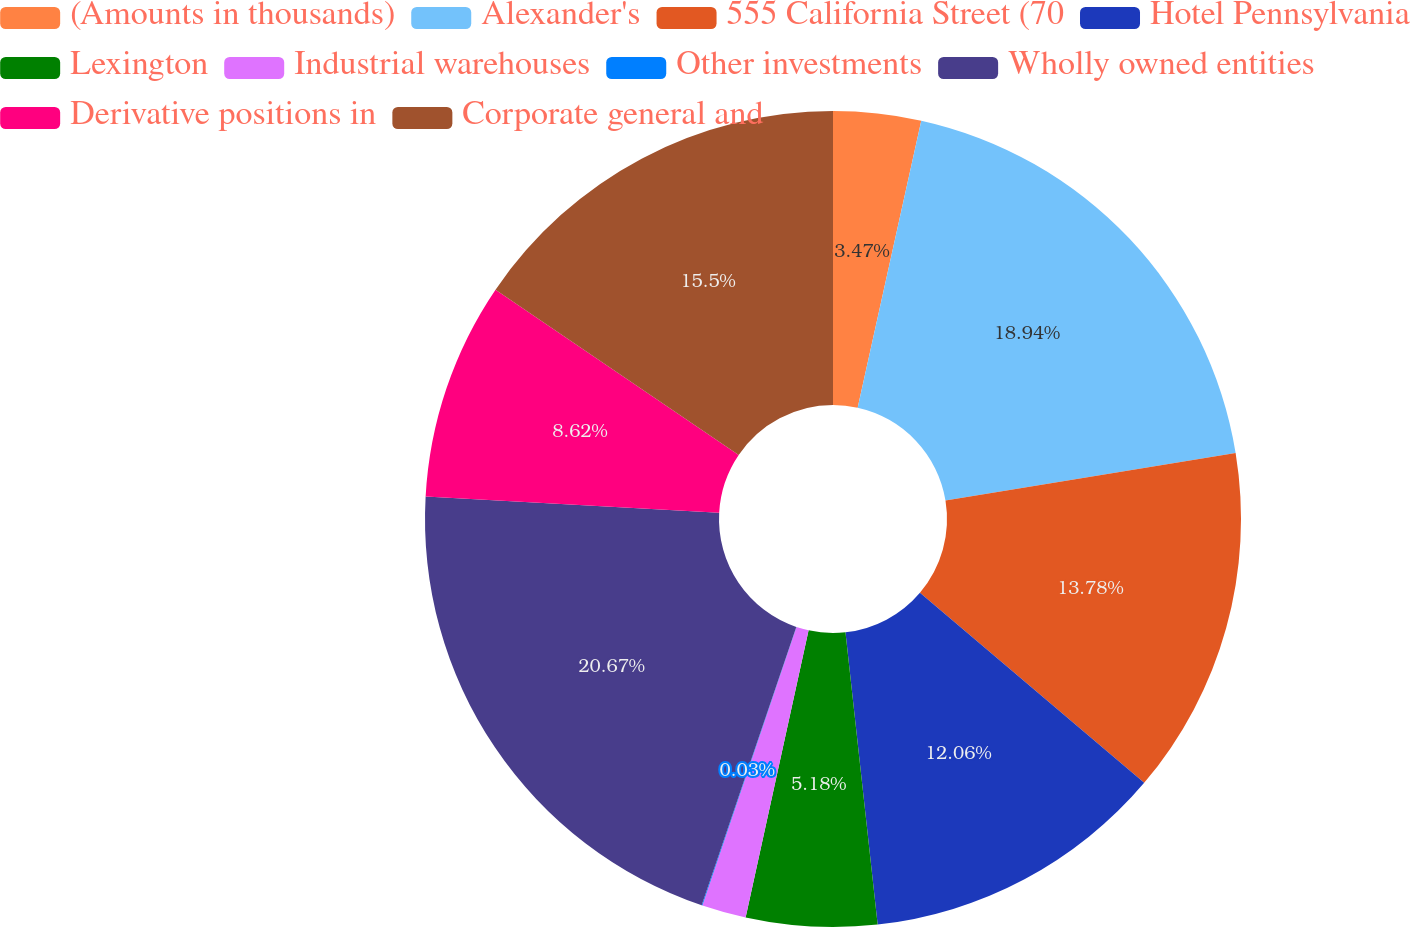Convert chart to OTSL. <chart><loc_0><loc_0><loc_500><loc_500><pie_chart><fcel>(Amounts in thousands)<fcel>Alexander's<fcel>555 California Street (70<fcel>Hotel Pennsylvania<fcel>Lexington<fcel>Industrial warehouses<fcel>Other investments<fcel>Wholly owned entities<fcel>Derivative positions in<fcel>Corporate general and<nl><fcel>3.47%<fcel>18.94%<fcel>13.78%<fcel>12.06%<fcel>5.18%<fcel>1.75%<fcel>0.03%<fcel>20.66%<fcel>8.62%<fcel>15.5%<nl></chart> 